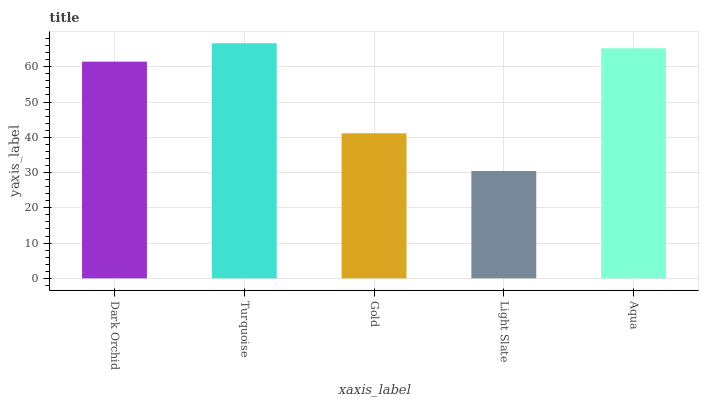Is Light Slate the minimum?
Answer yes or no. Yes. Is Turquoise the maximum?
Answer yes or no. Yes. Is Gold the minimum?
Answer yes or no. No. Is Gold the maximum?
Answer yes or no. No. Is Turquoise greater than Gold?
Answer yes or no. Yes. Is Gold less than Turquoise?
Answer yes or no. Yes. Is Gold greater than Turquoise?
Answer yes or no. No. Is Turquoise less than Gold?
Answer yes or no. No. Is Dark Orchid the high median?
Answer yes or no. Yes. Is Dark Orchid the low median?
Answer yes or no. Yes. Is Turquoise the high median?
Answer yes or no. No. Is Light Slate the low median?
Answer yes or no. No. 